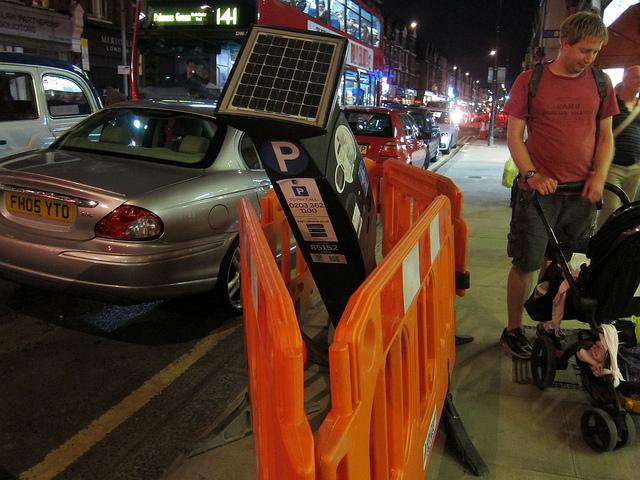Which make of vehicle is parked nearest to the meter?

Choices:
A) honda
B) jaguar
C) bmw
D) toyota jaguar 